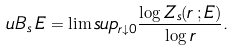<formula> <loc_0><loc_0><loc_500><loc_500>\ u B _ { s } \, E = \lim s u p _ { r \downarrow 0 } \frac { \log Z _ { s } ( r \, ; E ) } { \log r } .</formula> 